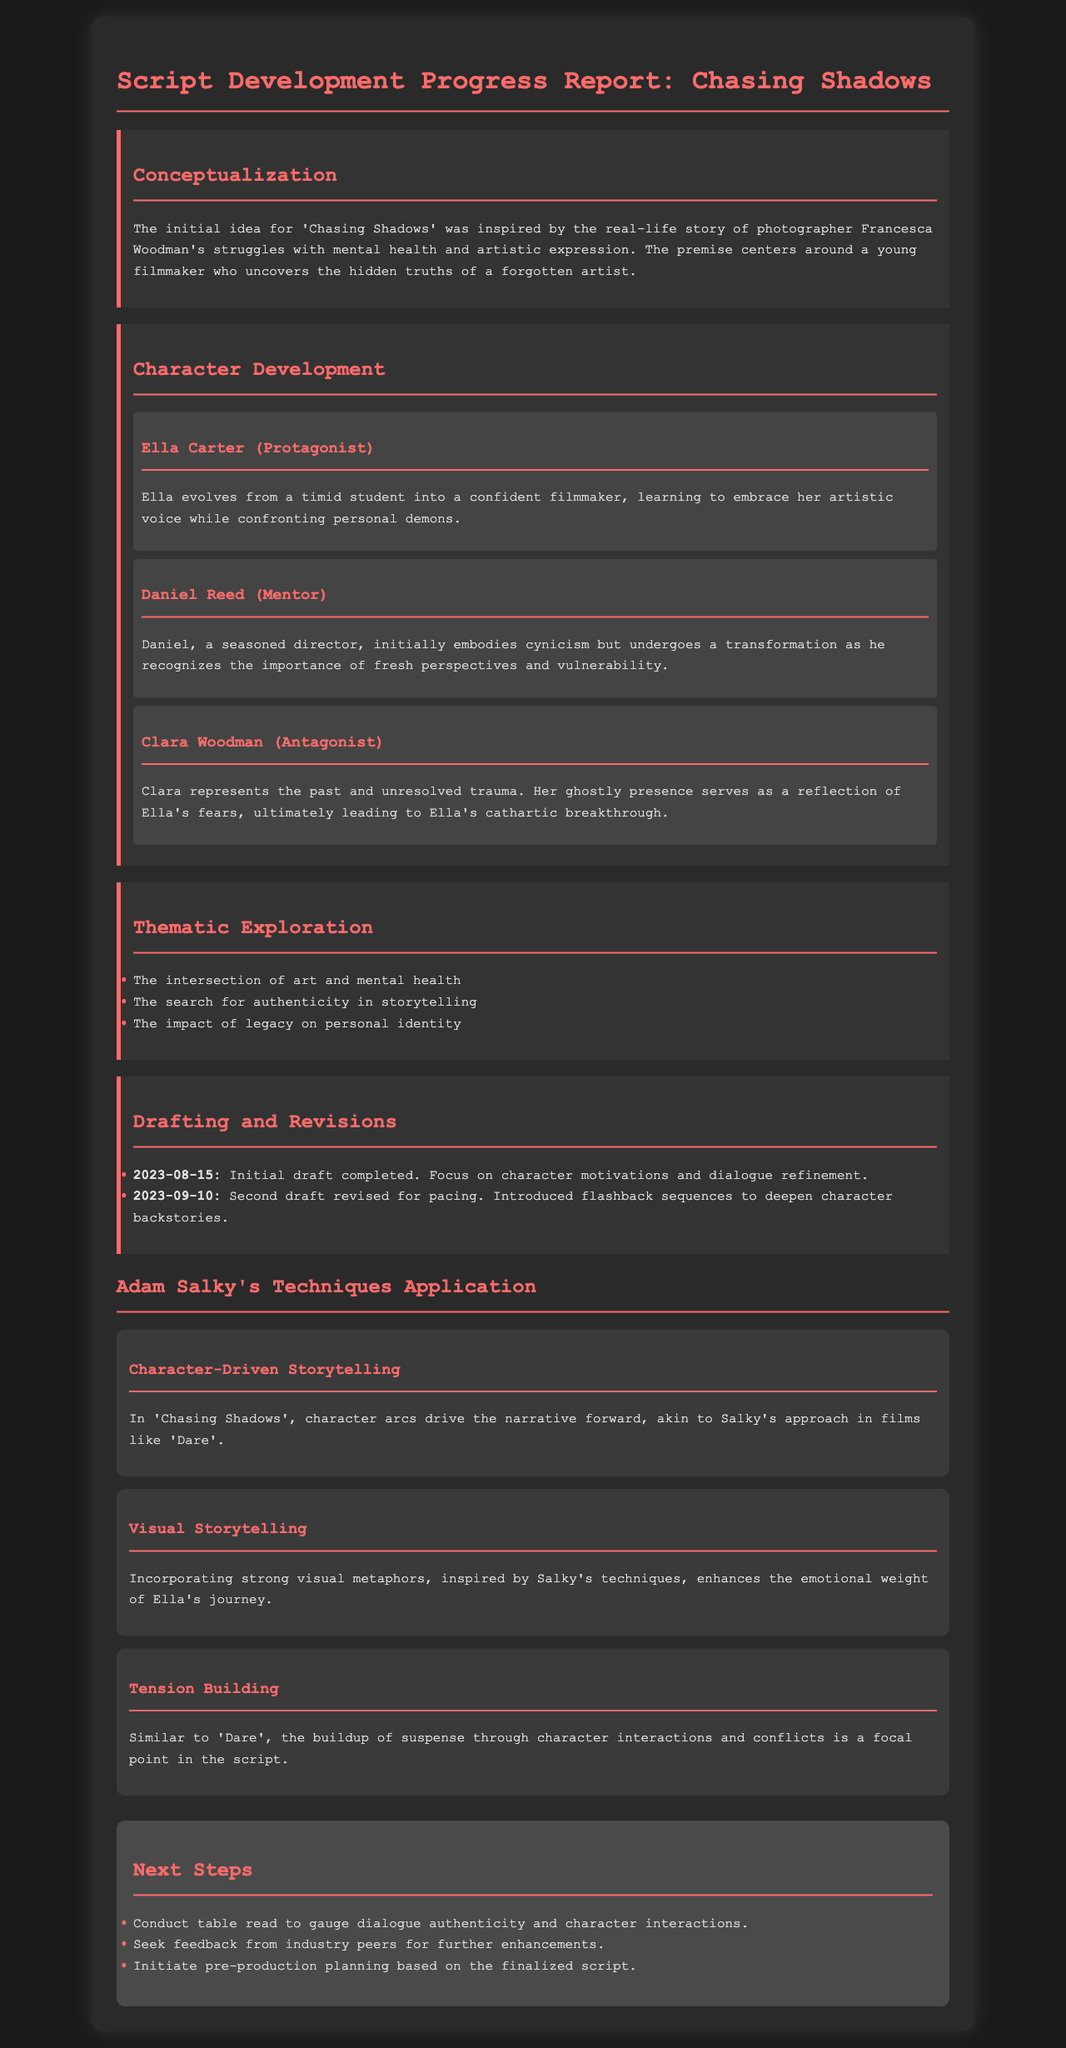What is the title of the film? The title of the film, as stated in the document, is 'Chasing Shadows'.
Answer: Chasing Shadows Who is the protagonist? The protagonist's name is provided in the character development section, which mentions Ella Carter.
Answer: Ella Carter When was the initial draft completed? The document specifies the date of the initial draft, which was completed on August 15, 2023.
Answer: 2023-08-15 What theme involves personal identity? The thematic exploration mentions the impact of legacy on personal identity.
Answer: The impact of legacy on personal identity Which technique focuses on character interactions? The document discusses tension building as a technique focusing on character interactions and conflicts.
Answer: Tension Building What transformation does Daniel experience? The document describes Daniel's transformation from cynicism to recognizing the importance of fresh perspectives.
Answer: Recognizing the importance of fresh perspectives What stage follows character development? The stages discussed in order show that thematic exploration follows character development.
Answer: Thematic Exploration How many next steps are listed? The document outlines three specific next steps for the script development process.
Answer: Three Which character evolves into a confident filmmaker? The character description for the protagonist clearly states Ella evolves into a confident filmmaker.
Answer: Ella Carter 